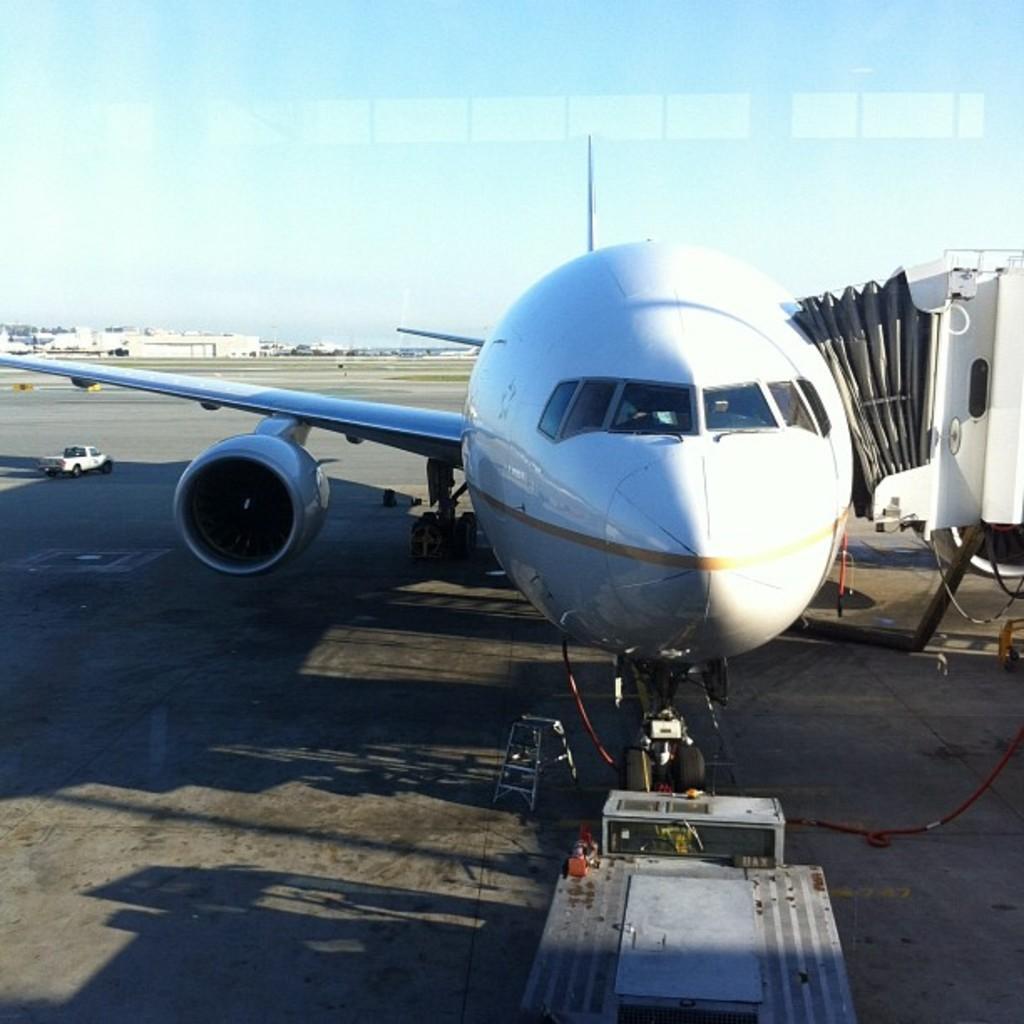Please provide a concise description of this image. In this picture we can see an airplane, vehicle, stand and objects on the surface. In the background of the image we can see buildings and sky. 